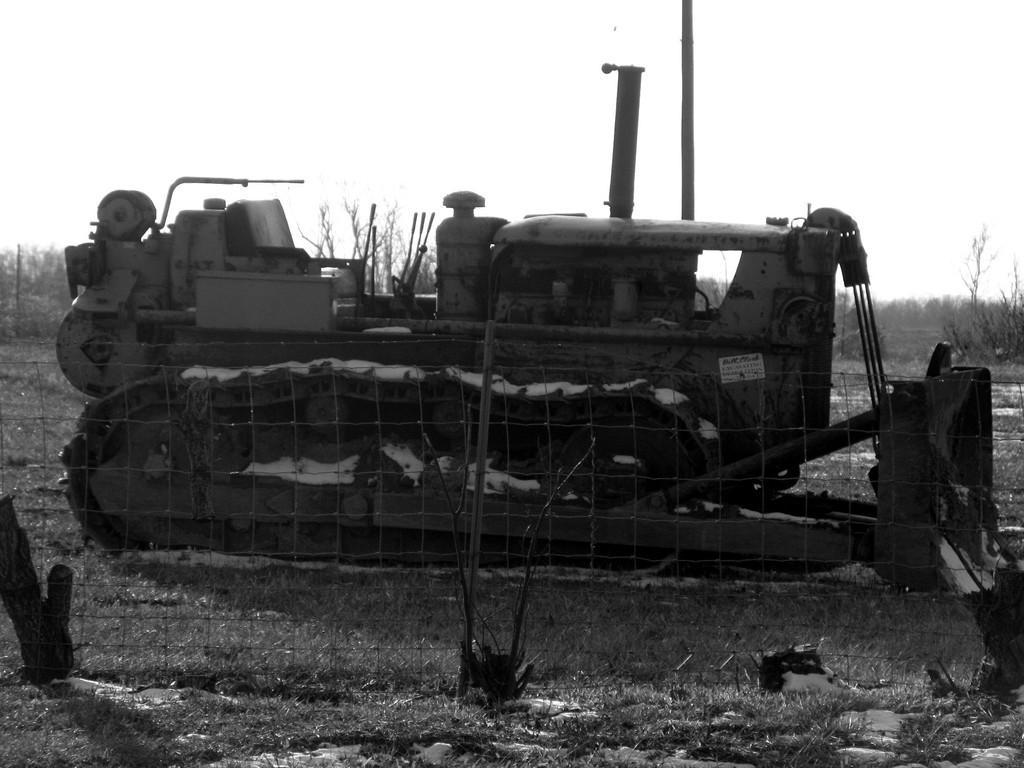Can you describe this image briefly? In this black and white image there is a vehicle and net fencing in the foreground and there are trees and sky in the background area. 